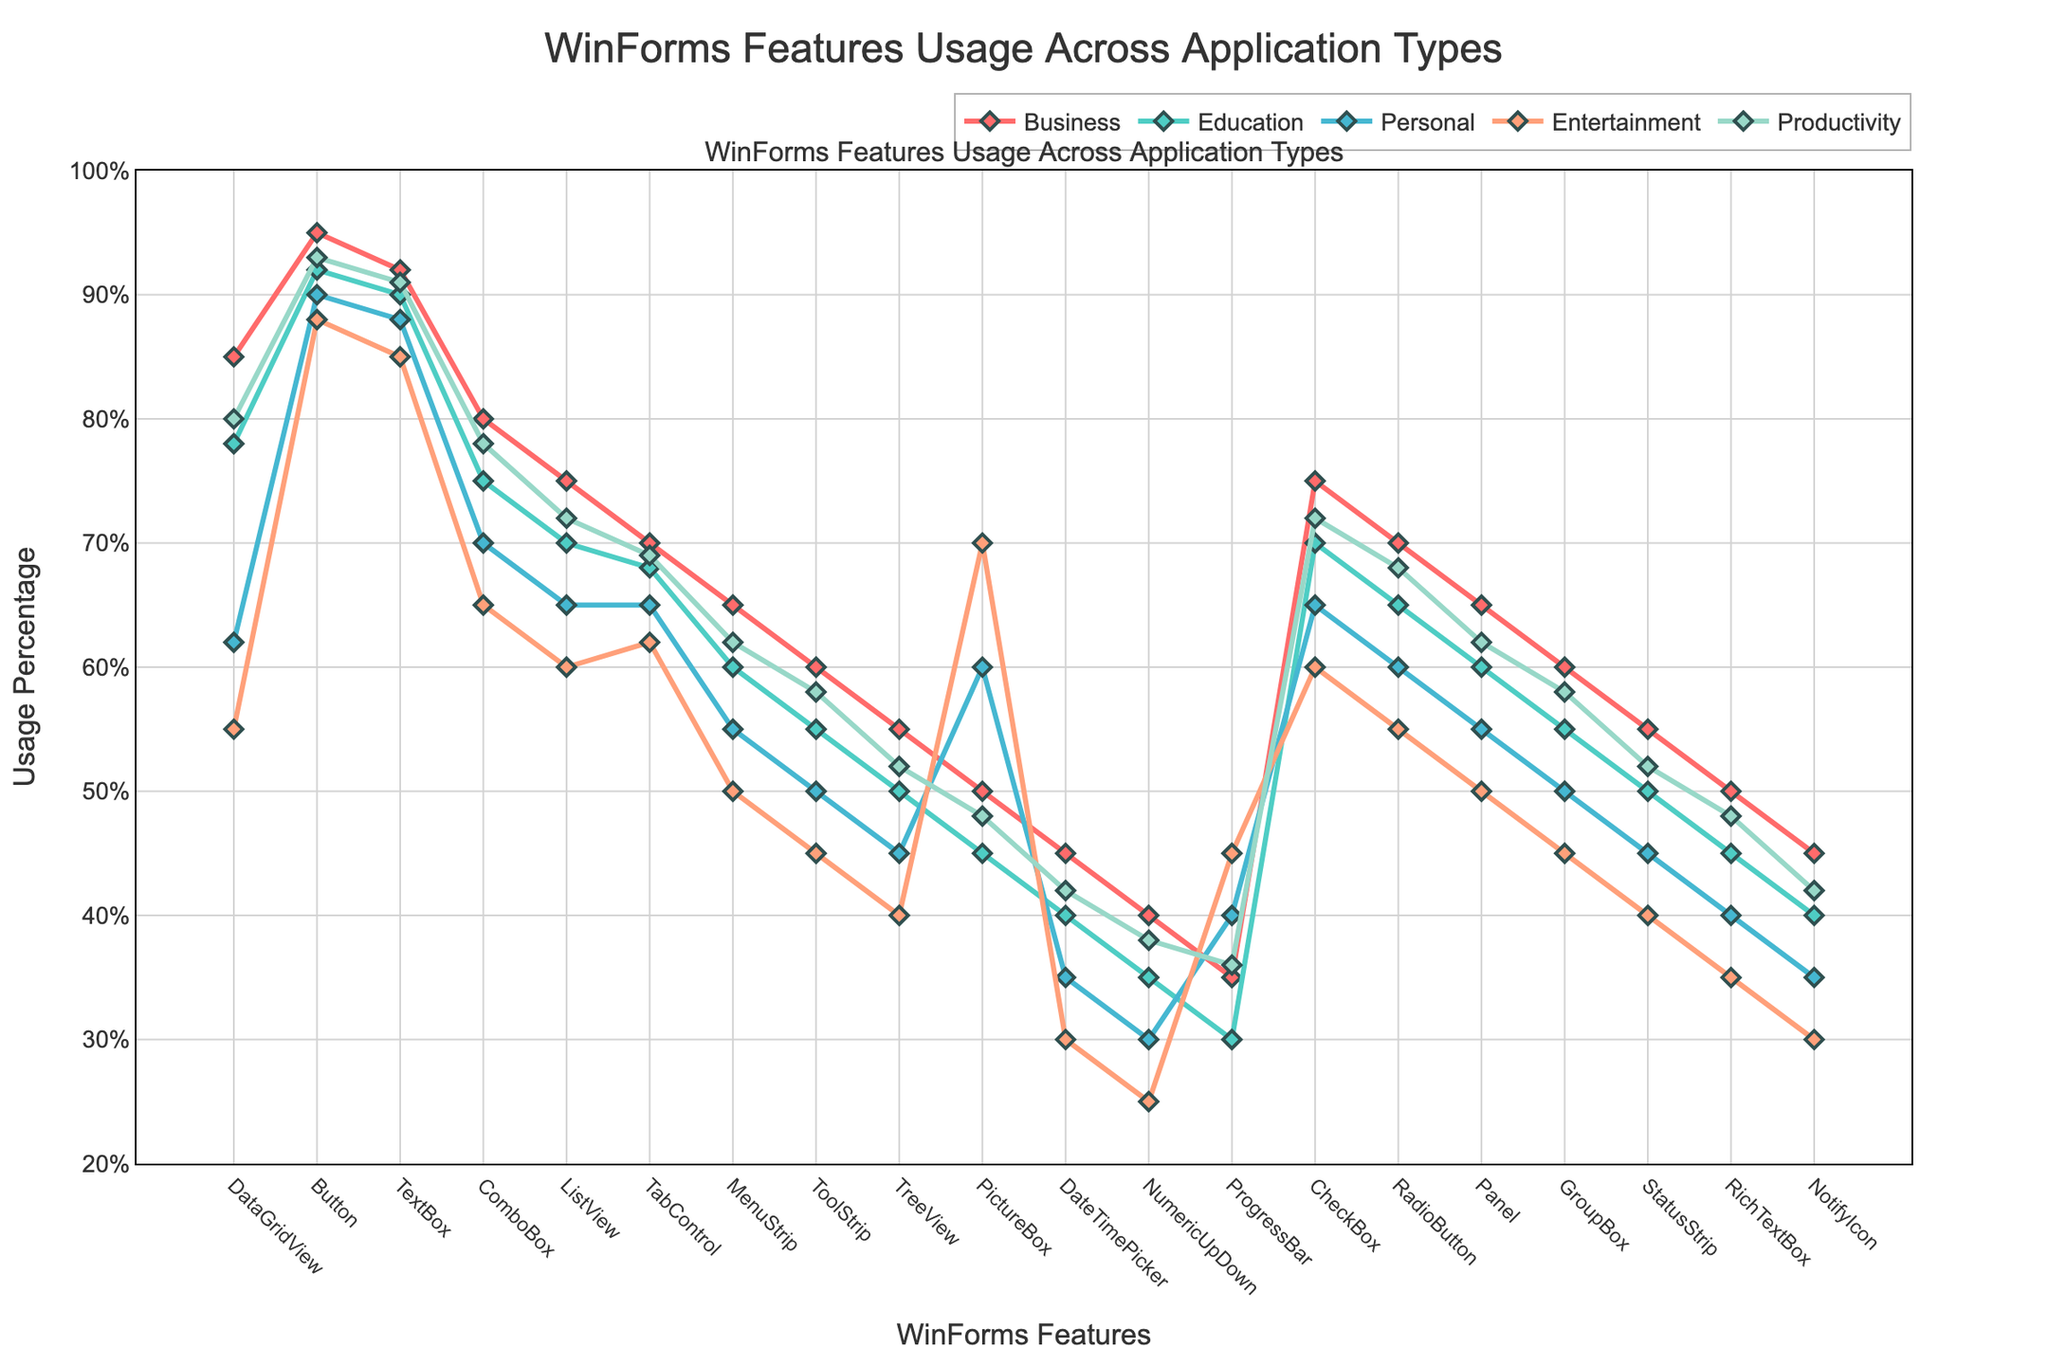What feature has the highest usage percentage in the Business application type? By looking at the plot lines, the Business application type is represented with a red line. The feature with the highest point on the red line is the Button feature.
Answer: Button Which application type shows the highest usage of the PictureBox feature? The PictureBox feature’s usage can be determined by observing the peaks of its respective points across different colored lines representing different application types. The highest point for the PictureBox feature occurs in the Entertainment application type represented by the orange line.
Answer: Entertainment Compare the usage percentage of the ProgressBar feature in Business and Entertainment application types. Which is higher? By locating the ProgressBar feature on the x-axis, we can compare its corresponding points on the red line representing Business and the blue line representing Entertainment. The red line is at 35%, while the blue line is at 45%. Therefore, the usage is higher in Entertainment.
Answer: Entertainment What feature has the lowest usage percentage in the Personal application type? To find the lowest usage percentage in the Personal application type, follow the purple line down to the lowest point, which is 25% for the NumericUpDown feature.
Answer: NumericUpDown What is the average usage percentage of the DateTimePicker feature across all application types? The DateTimePicker feature has usage percentages of 45, 40, 35, 30, and 42 in Business, Education, Personal, Entertainment, and Productivity application types, respectively. The average usage is calculated as (45+40+35+30+42)/5 = 38.4%.
Answer: 38.4% Which type of application has the smallest range of usage percentages across all features? To determine the smallest range of usage percentages, calculate the difference between the highest and lowest values for each application type. The application type with the smallest range can be identified by visualizing the distances between peaks and troughs for each colored line. By observation, the Education application type (green line) consistently maintains a narrow range of values.
Answer: Education Compare the usage of CheckBox and RadioButton features in the Productivity application type. Are they equal or different? Both the CheckBox and RadioButton are plotted on the graph for the Productivity (purple line). By observing the heights of these two points, it’s clear they align at 72% and 68%, respectively, thus they are different.
Answer: Different Which feature shows the largest difference in usage percentage between Business and Personal application types? To find the largest difference, compare the respective points for Business (red) and Personal (blue) for each feature. The ComboBox feature has the highest difference, from 80 in Business to 70 in Personal, equating to a 20% difference.
Answer: ComboBox 